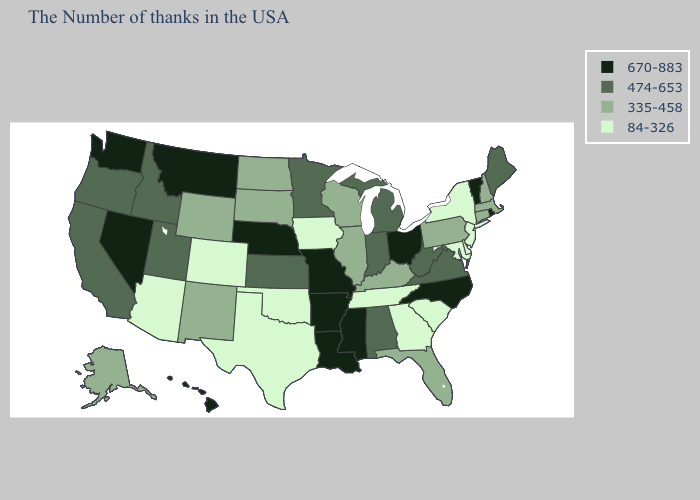Among the states that border Vermont , which have the lowest value?
Be succinct. New York. Does Iowa have the lowest value in the USA?
Answer briefly. Yes. What is the value of Kansas?
Short answer required. 474-653. Among the states that border South Dakota , which have the lowest value?
Quick response, please. Iowa. Does the first symbol in the legend represent the smallest category?
Quick response, please. No. Which states hav the highest value in the MidWest?
Write a very short answer. Ohio, Missouri, Nebraska. What is the value of Pennsylvania?
Keep it brief. 335-458. What is the lowest value in the USA?
Write a very short answer. 84-326. Name the states that have a value in the range 670-883?
Be succinct. Rhode Island, Vermont, North Carolina, Ohio, Mississippi, Louisiana, Missouri, Arkansas, Nebraska, Montana, Nevada, Washington, Hawaii. What is the value of Texas?
Quick response, please. 84-326. Name the states that have a value in the range 335-458?
Be succinct. Massachusetts, New Hampshire, Connecticut, Pennsylvania, Florida, Kentucky, Wisconsin, Illinois, South Dakota, North Dakota, Wyoming, New Mexico, Alaska. Name the states that have a value in the range 335-458?
Answer briefly. Massachusetts, New Hampshire, Connecticut, Pennsylvania, Florida, Kentucky, Wisconsin, Illinois, South Dakota, North Dakota, Wyoming, New Mexico, Alaska. Does the first symbol in the legend represent the smallest category?
Write a very short answer. No. Does the first symbol in the legend represent the smallest category?
Give a very brief answer. No. Which states hav the highest value in the South?
Short answer required. North Carolina, Mississippi, Louisiana, Arkansas. 